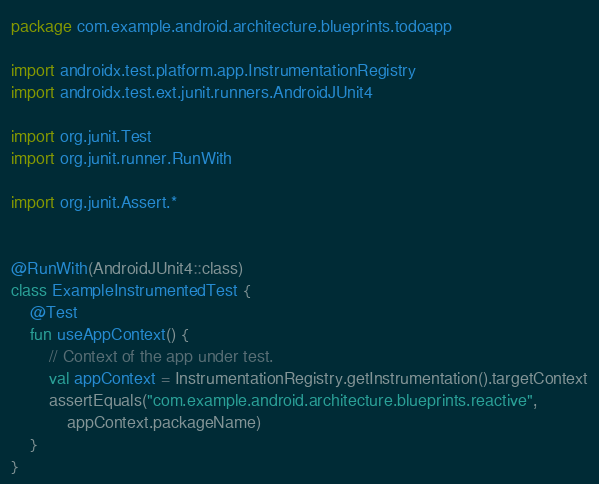Convert code to text. <code><loc_0><loc_0><loc_500><loc_500><_Kotlin_>package com.example.android.architecture.blueprints.todoapp

import androidx.test.platform.app.InstrumentationRegistry
import androidx.test.ext.junit.runners.AndroidJUnit4

import org.junit.Test
import org.junit.runner.RunWith

import org.junit.Assert.*


@RunWith(AndroidJUnit4::class)
class ExampleInstrumentedTest {
    @Test
    fun useAppContext() {
        // Context of the app under test.
        val appContext = InstrumentationRegistry.getInstrumentation().targetContext
        assertEquals("com.example.android.architecture.blueprints.reactive",
            appContext.packageName)
    }
}
</code> 